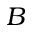Convert formula to latex. <formula><loc_0><loc_0><loc_500><loc_500>B</formula> 